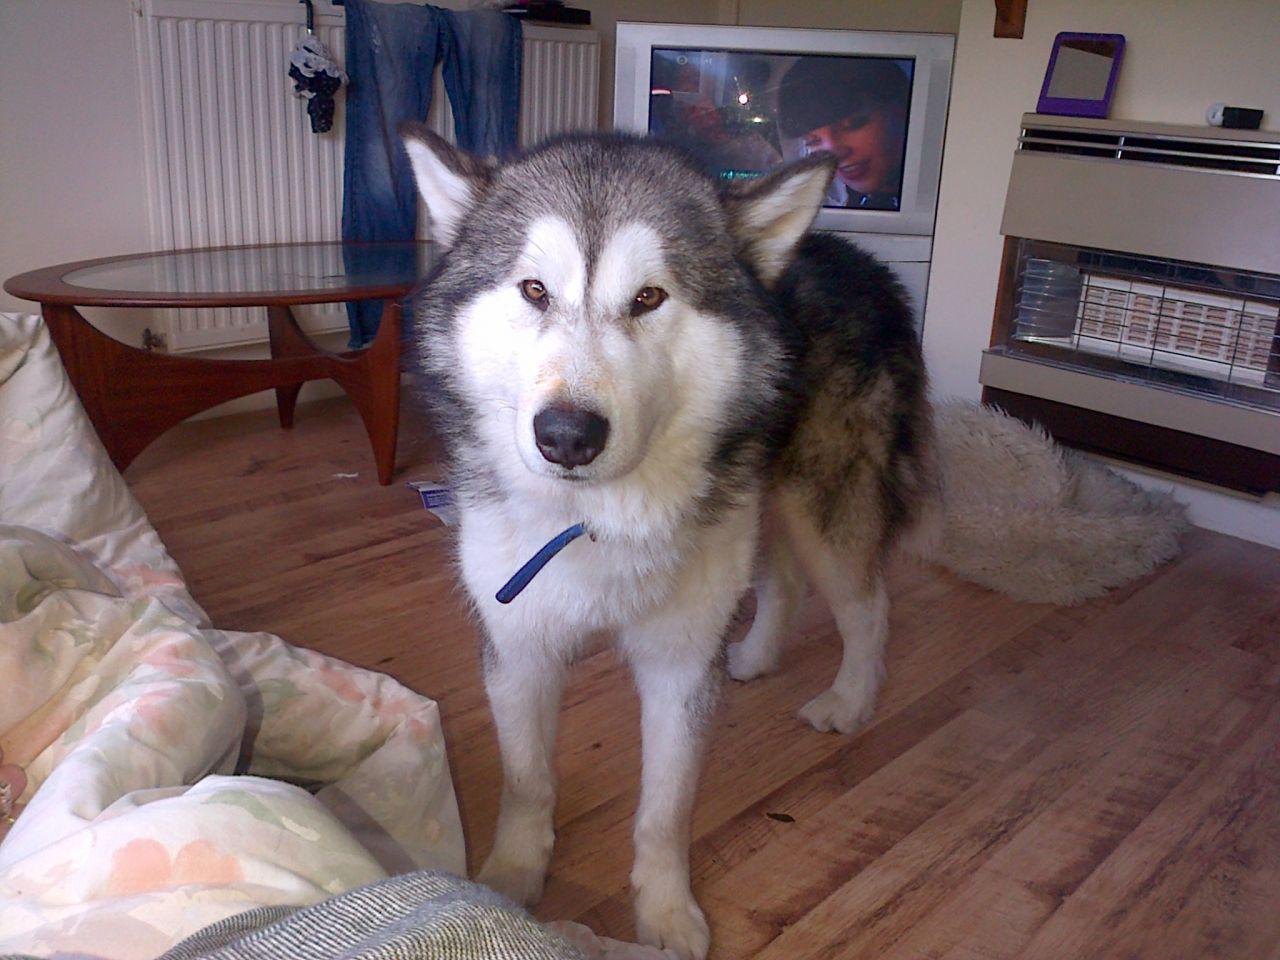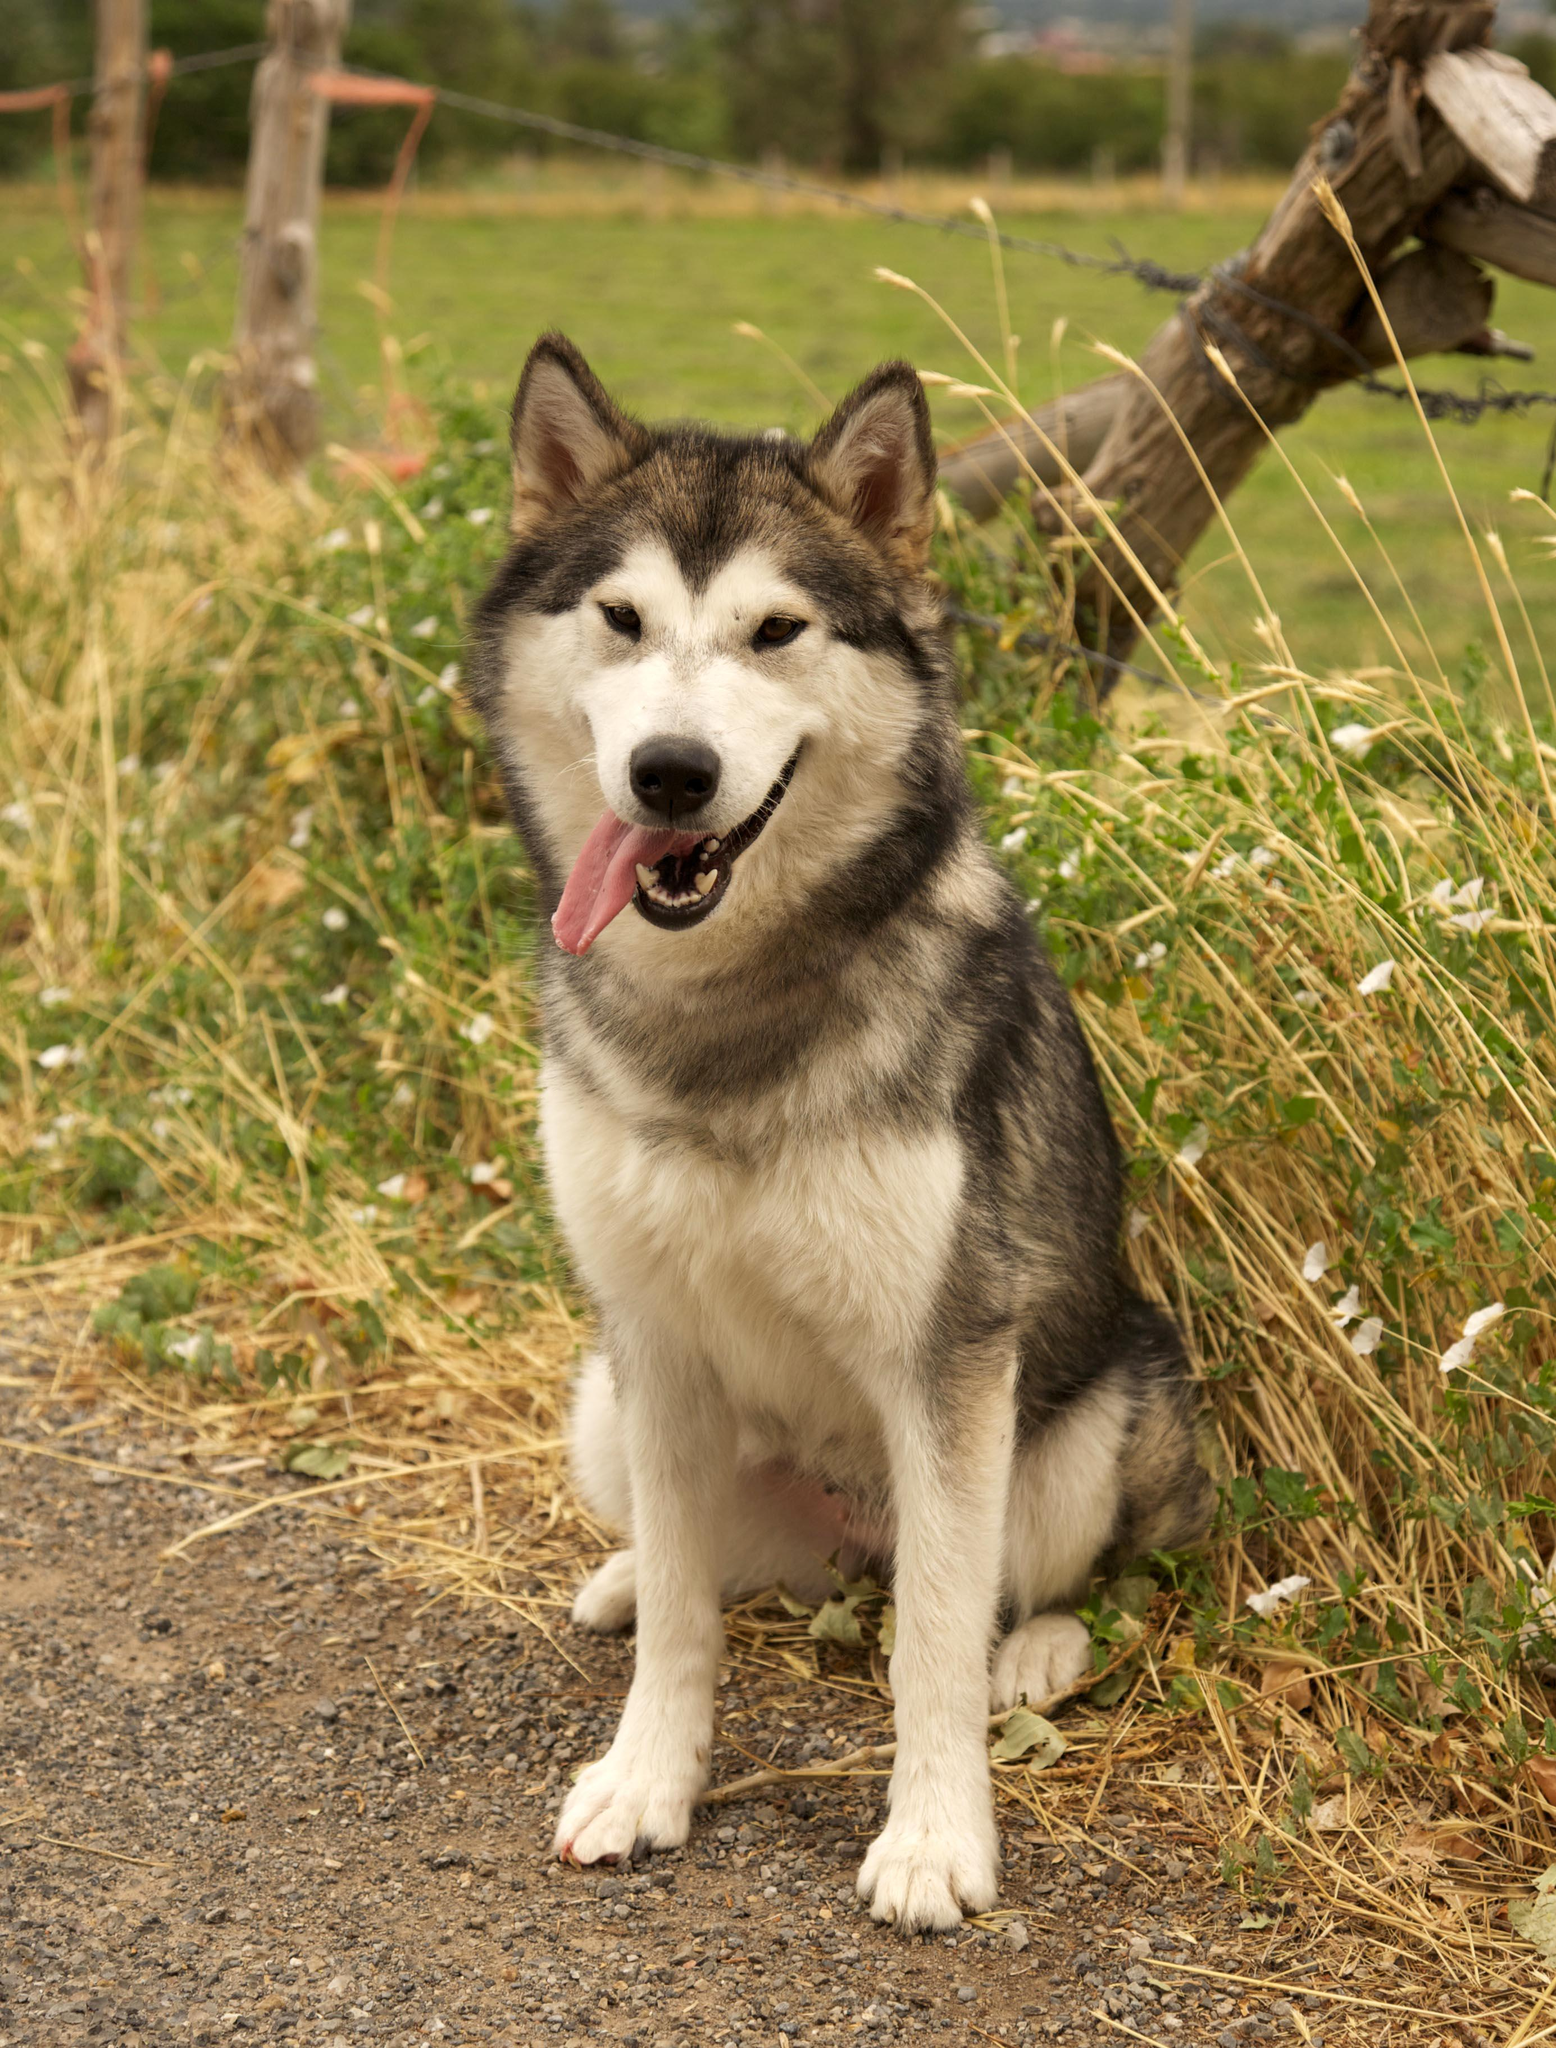The first image is the image on the left, the second image is the image on the right. For the images shown, is this caption "One image shows a dog sitting upright, and the other image features a dog standing on all fours." true? Answer yes or no. Yes. The first image is the image on the left, the second image is the image on the right. Examine the images to the left and right. Is the description "At least one dog is on a leash." accurate? Answer yes or no. No. 